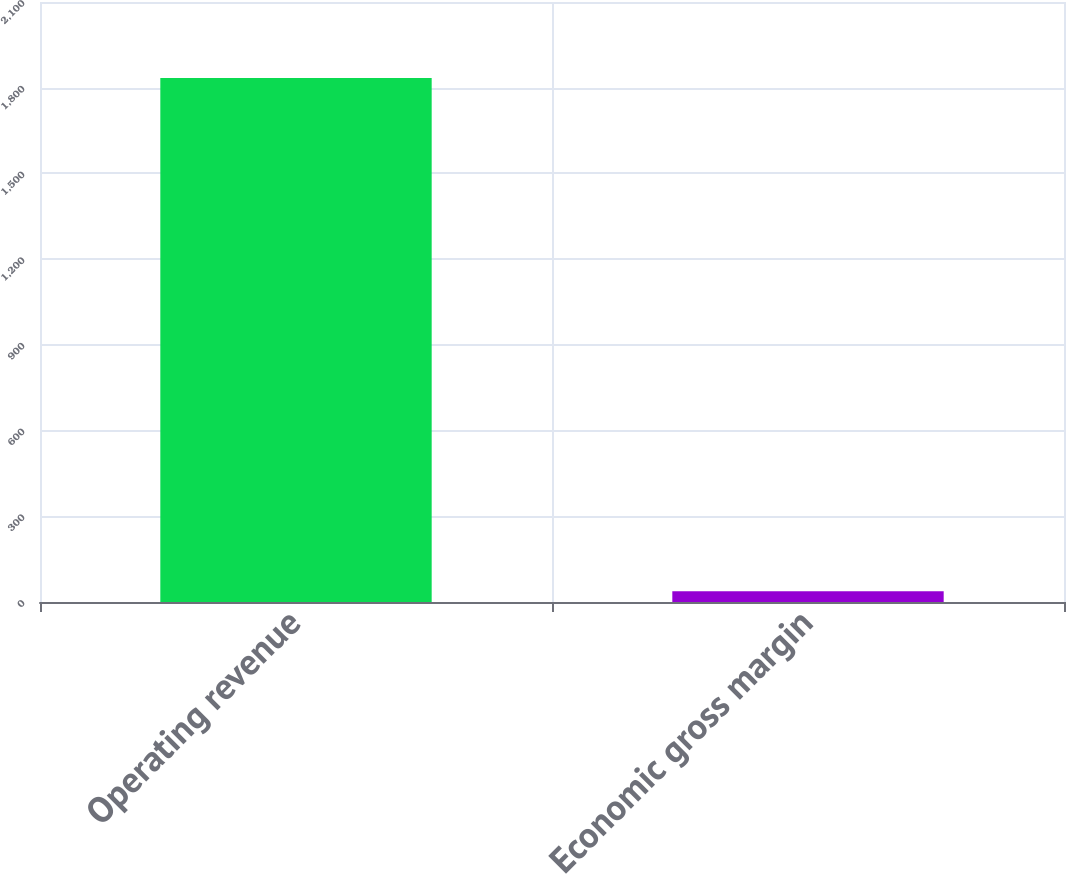<chart> <loc_0><loc_0><loc_500><loc_500><bar_chart><fcel>Operating revenue<fcel>Economic gross margin<nl><fcel>1834<fcel>38<nl></chart> 